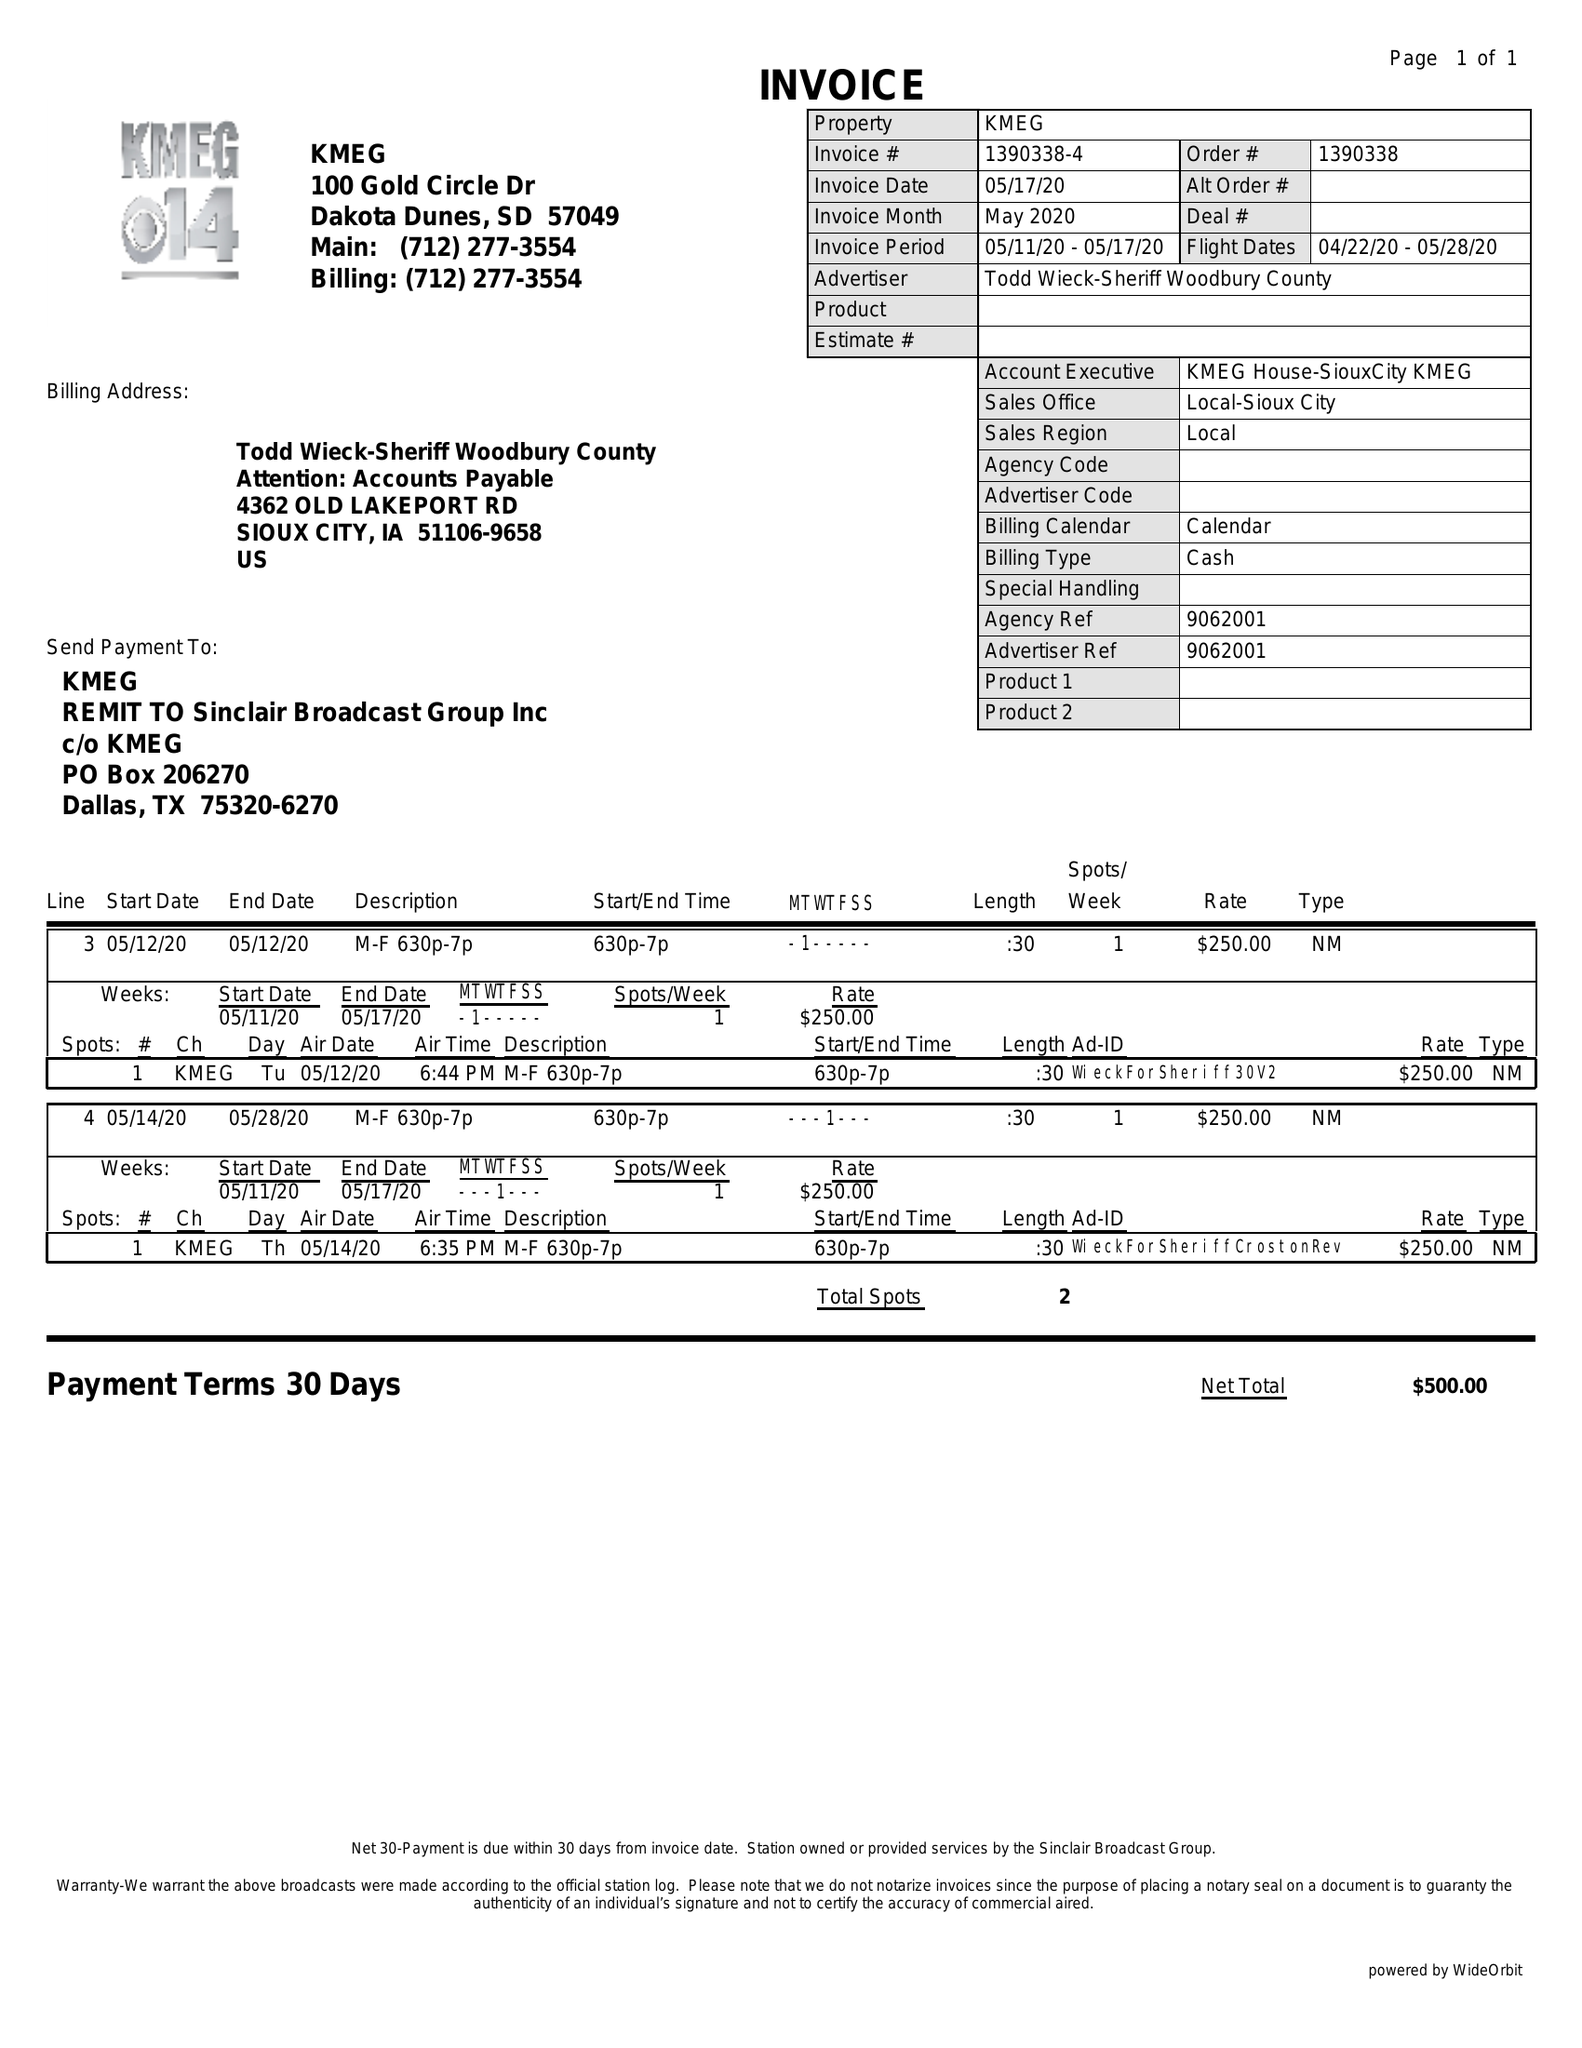What is the value for the contract_num?
Answer the question using a single word or phrase. 1390338 